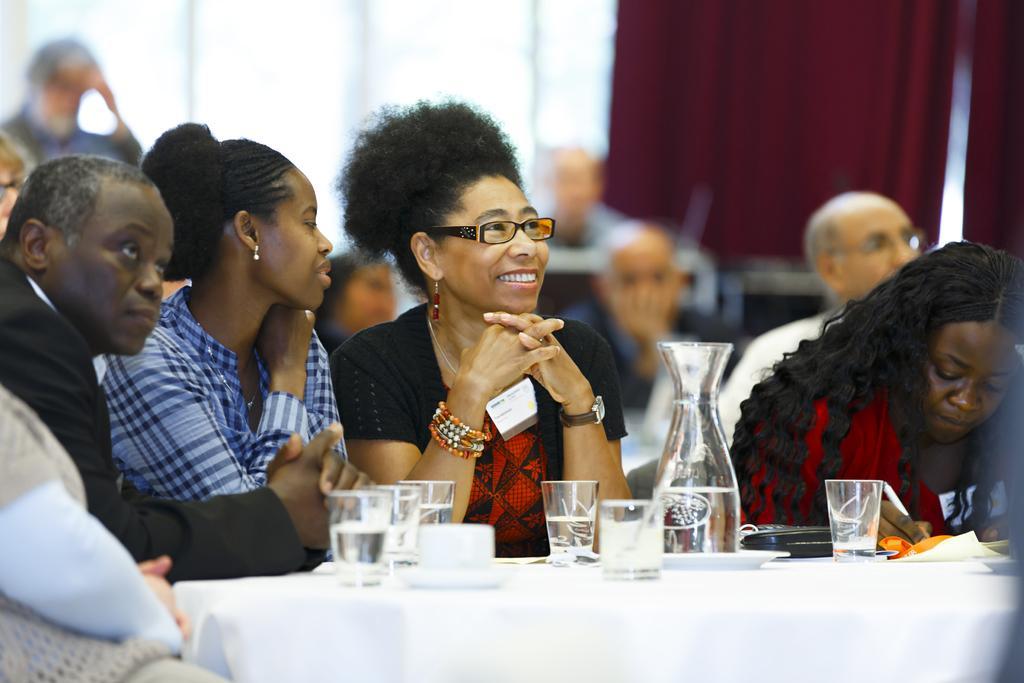Describe this image in one or two sentences. This image has three women sitting in front of table and at the left side there is a person sitting wearing black suit. At background there are few people sitting. There is a table in front having glasses and jar on it. 